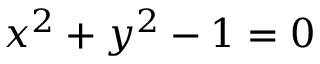Convert formula to latex. <formula><loc_0><loc_0><loc_500><loc_500>x ^ { 2 } + y ^ { 2 } - 1 = 0</formula> 